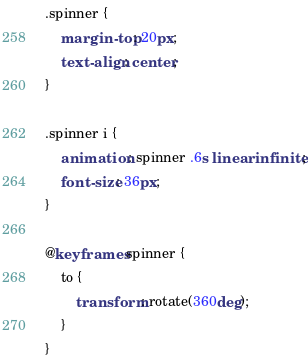Convert code to text. <code><loc_0><loc_0><loc_500><loc_500><_CSS_>.spinner {
    margin-top: 20px;
    text-align: center;
}

.spinner i {
    animation: spinner .6s linear infinite;
    font-size: 36px;
}

@keyframes spinner {
    to {
        transform: rotate(360deg);
    }
}</code> 